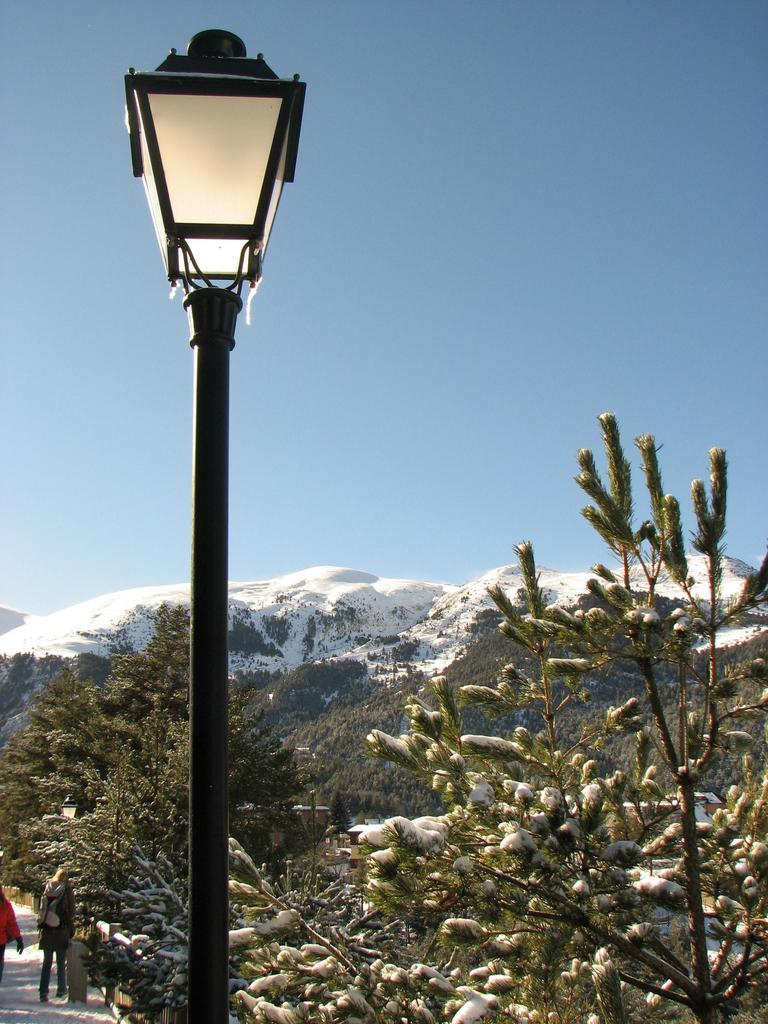What type of living organisms can be seen in the image? Plants can be seen in the image. What structure is present at the bottom of the image? There is a pole in the image. Where are the pole and plants located in relation to the image? The pole and plants are at the bottom of the image. What natural feature can be seen in the background of the image? There is a mountain in the background of the image. What is visible at the top of the image? The sky is visible at the top of the image. How many feet are visible in the image? There are no feet present in the image. What type of error can be seen in the image? There is no error present in the image. 